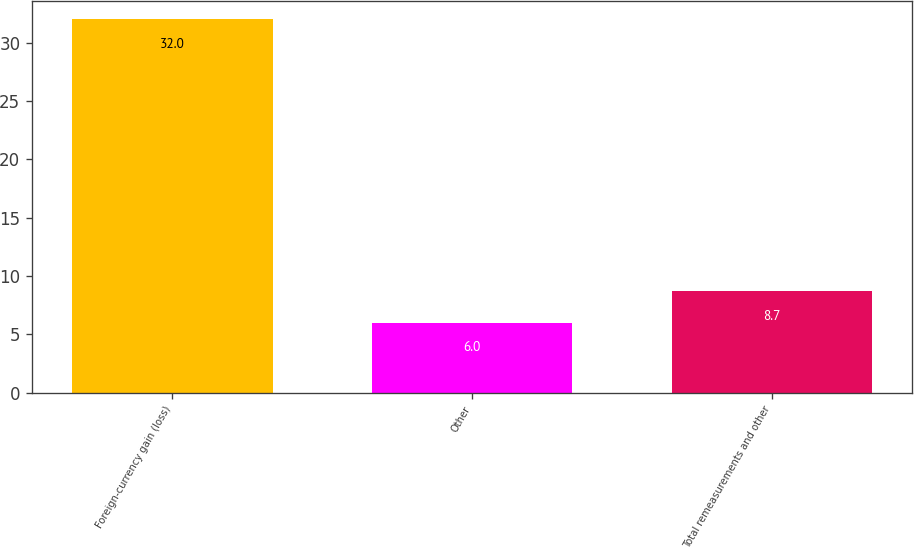Convert chart to OTSL. <chart><loc_0><loc_0><loc_500><loc_500><bar_chart><fcel>Foreign-currency gain (loss)<fcel>Other<fcel>Total remeasurements and other<nl><fcel>32<fcel>6<fcel>8.7<nl></chart> 